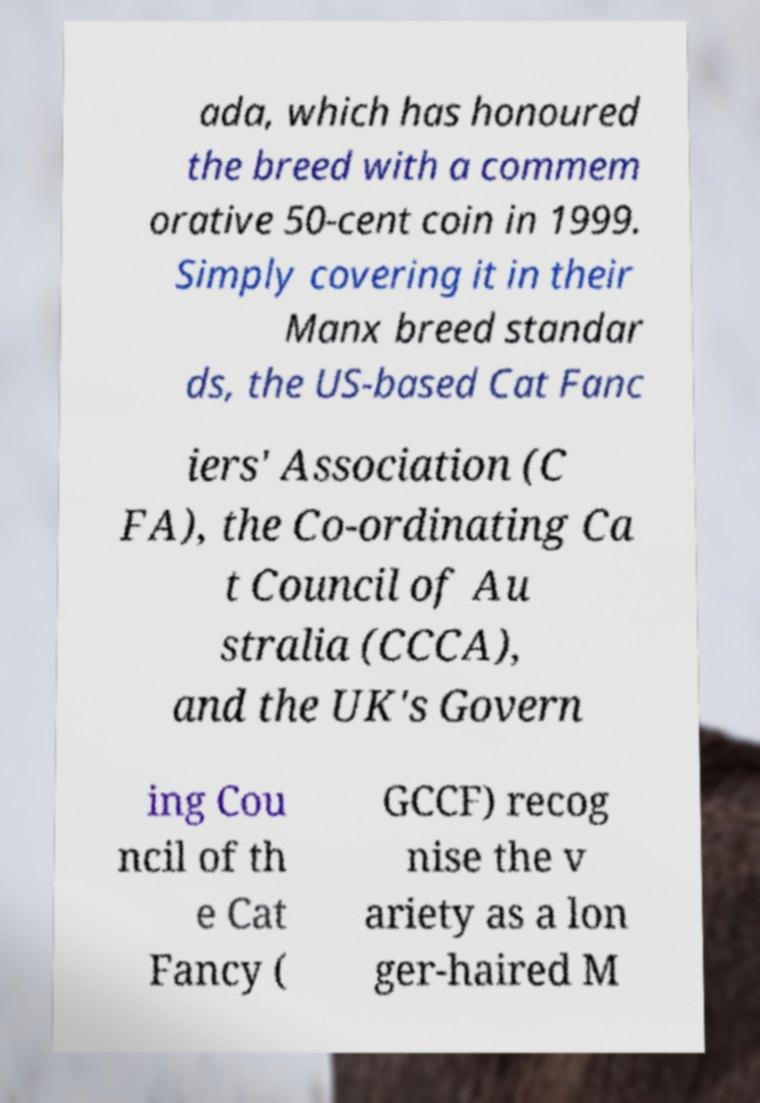There's text embedded in this image that I need extracted. Can you transcribe it verbatim? ada, which has honoured the breed with a commem orative 50-cent coin in 1999. Simply covering it in their Manx breed standar ds, the US-based Cat Fanc iers' Association (C FA), the Co-ordinating Ca t Council of Au stralia (CCCA), and the UK's Govern ing Cou ncil of th e Cat Fancy ( GCCF) recog nise the v ariety as a lon ger-haired M 